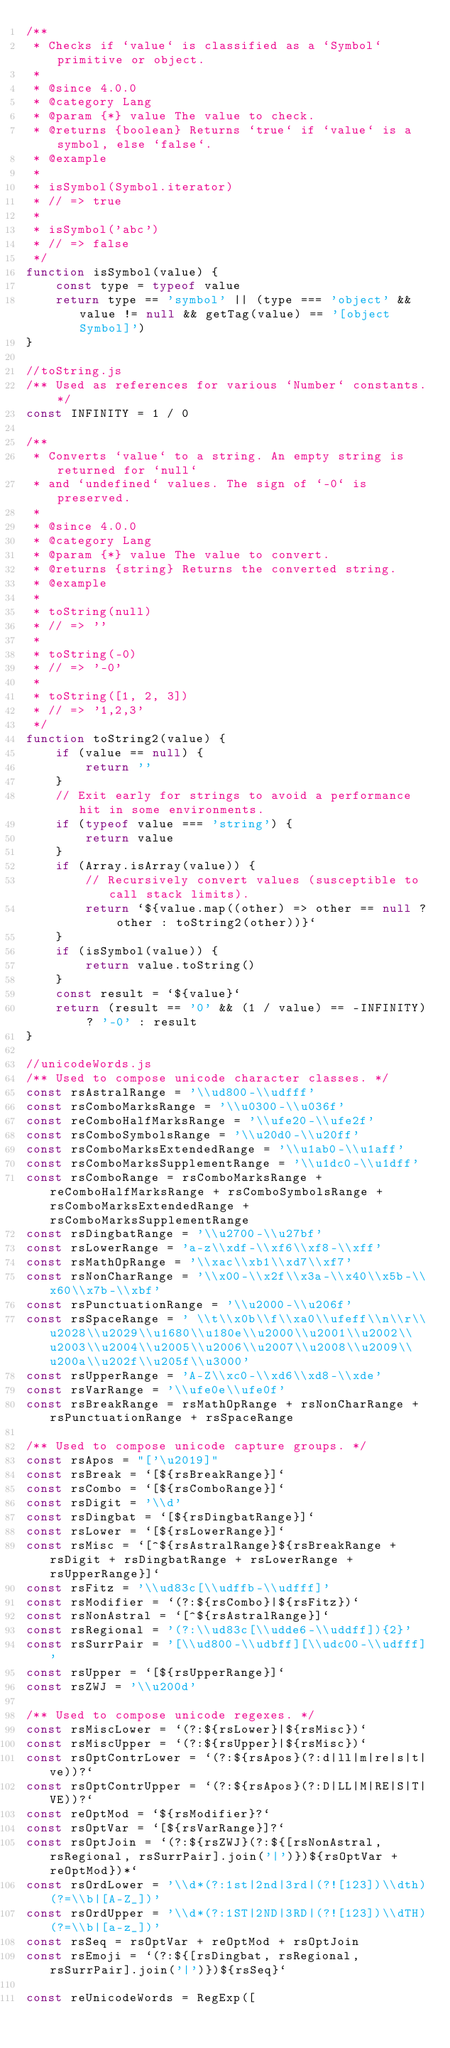Convert code to text. <code><loc_0><loc_0><loc_500><loc_500><_JavaScript_>/**
 * Checks if `value` is classified as a `Symbol` primitive or object.
 *
 * @since 4.0.0
 * @category Lang
 * @param {*} value The value to check.
 * @returns {boolean} Returns `true` if `value` is a symbol, else `false`.
 * @example
 *
 * isSymbol(Symbol.iterator)
 * // => true
 *
 * isSymbol('abc')
 * // => false
 */
function isSymbol(value) {
    const type = typeof value
    return type == 'symbol' || (type === 'object' && value != null && getTag(value) == '[object Symbol]')
}

//toString.js
/** Used as references for various `Number` constants. */
const INFINITY = 1 / 0

/**
 * Converts `value` to a string. An empty string is returned for `null`
 * and `undefined` values. The sign of `-0` is preserved.
 *
 * @since 4.0.0
 * @category Lang
 * @param {*} value The value to convert.
 * @returns {string} Returns the converted string.
 * @example
 *
 * toString(null)
 * // => ''
 *
 * toString(-0)
 * // => '-0'
 *
 * toString([1, 2, 3])
 * // => '1,2,3'
 */
function toString2(value) {
    if (value == null) {
        return ''
    }
    // Exit early for strings to avoid a performance hit in some environments.
    if (typeof value === 'string') {
        return value
    }
    if (Array.isArray(value)) {
        // Recursively convert values (susceptible to call stack limits).
        return `${value.map((other) => other == null ? other : toString2(other))}`
    }
    if (isSymbol(value)) {
        return value.toString()
    }
    const result = `${value}`
    return (result == '0' && (1 / value) == -INFINITY) ? '-0' : result
}

//unicodeWords.js
/** Used to compose unicode character classes. */
const rsAstralRange = '\\ud800-\\udfff'
const rsComboMarksRange = '\\u0300-\\u036f'
const reComboHalfMarksRange = '\\ufe20-\\ufe2f'
const rsComboSymbolsRange = '\\u20d0-\\u20ff'
const rsComboMarksExtendedRange = '\\u1ab0-\\u1aff'
const rsComboMarksSupplementRange = '\\u1dc0-\\u1dff'
const rsComboRange = rsComboMarksRange + reComboHalfMarksRange + rsComboSymbolsRange + rsComboMarksExtendedRange + rsComboMarksSupplementRange
const rsDingbatRange = '\\u2700-\\u27bf'
const rsLowerRange = 'a-z\\xdf-\\xf6\\xf8-\\xff'
const rsMathOpRange = '\\xac\\xb1\\xd7\\xf7'
const rsNonCharRange = '\\x00-\\x2f\\x3a-\\x40\\x5b-\\x60\\x7b-\\xbf'
const rsPunctuationRange = '\\u2000-\\u206f'
const rsSpaceRange = ' \\t\\x0b\\f\\xa0\\ufeff\\n\\r\\u2028\\u2029\\u1680\\u180e\\u2000\\u2001\\u2002\\u2003\\u2004\\u2005\\u2006\\u2007\\u2008\\u2009\\u200a\\u202f\\u205f\\u3000'
const rsUpperRange = 'A-Z\\xc0-\\xd6\\xd8-\\xde'
const rsVarRange = '\\ufe0e\\ufe0f'
const rsBreakRange = rsMathOpRange + rsNonCharRange + rsPunctuationRange + rsSpaceRange

/** Used to compose unicode capture groups. */
const rsApos = "['\u2019]"
const rsBreak = `[${rsBreakRange}]`
const rsCombo = `[${rsComboRange}]`
const rsDigit = '\\d'
const rsDingbat = `[${rsDingbatRange}]`
const rsLower = `[${rsLowerRange}]`
const rsMisc = `[^${rsAstralRange}${rsBreakRange + rsDigit + rsDingbatRange + rsLowerRange + rsUpperRange}]`
const rsFitz = '\\ud83c[\\udffb-\\udfff]'
const rsModifier = `(?:${rsCombo}|${rsFitz})`
const rsNonAstral = `[^${rsAstralRange}]`
const rsRegional = '(?:\\ud83c[\\udde6-\\uddff]){2}'
const rsSurrPair = '[\\ud800-\\udbff][\\udc00-\\udfff]'
const rsUpper = `[${rsUpperRange}]`
const rsZWJ = '\\u200d'

/** Used to compose unicode regexes. */
const rsMiscLower = `(?:${rsLower}|${rsMisc})`
const rsMiscUpper = `(?:${rsUpper}|${rsMisc})`
const rsOptContrLower = `(?:${rsApos}(?:d|ll|m|re|s|t|ve))?`
const rsOptContrUpper = `(?:${rsApos}(?:D|LL|M|RE|S|T|VE))?`
const reOptMod = `${rsModifier}?`
const rsOptVar = `[${rsVarRange}]?`
const rsOptJoin = `(?:${rsZWJ}(?:${[rsNonAstral, rsRegional, rsSurrPair].join('|')})${rsOptVar + reOptMod})*`
const rsOrdLower = '\\d*(?:1st|2nd|3rd|(?![123])\\dth)(?=\\b|[A-Z_])'
const rsOrdUpper = '\\d*(?:1ST|2ND|3RD|(?![123])\\dTH)(?=\\b|[a-z_])'
const rsSeq = rsOptVar + reOptMod + rsOptJoin
const rsEmoji = `(?:${[rsDingbat, rsRegional, rsSurrPair].join('|')})${rsSeq}`

const reUnicodeWords = RegExp([</code> 